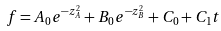<formula> <loc_0><loc_0><loc_500><loc_500>f = A _ { 0 } e ^ { - z _ { A } ^ { 2 } } + B _ { 0 } e ^ { - z _ { B } ^ { 2 } } + C _ { 0 } + C _ { 1 } t</formula> 